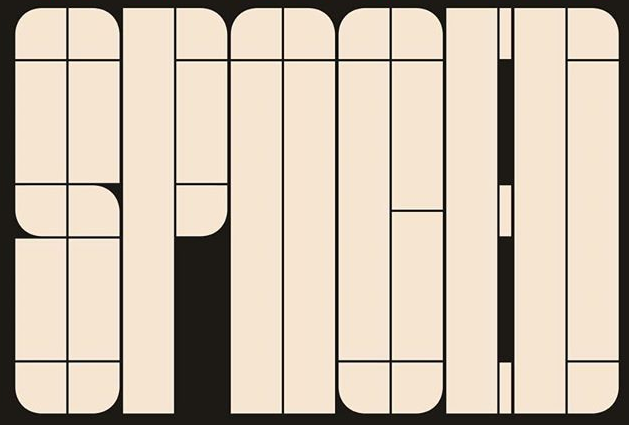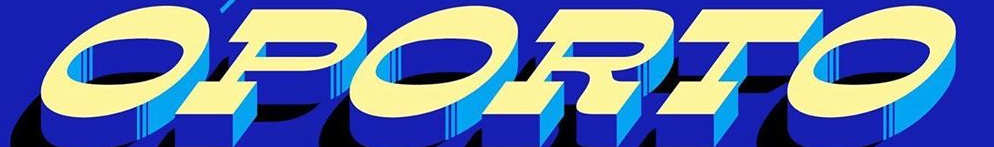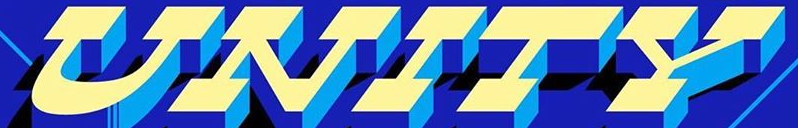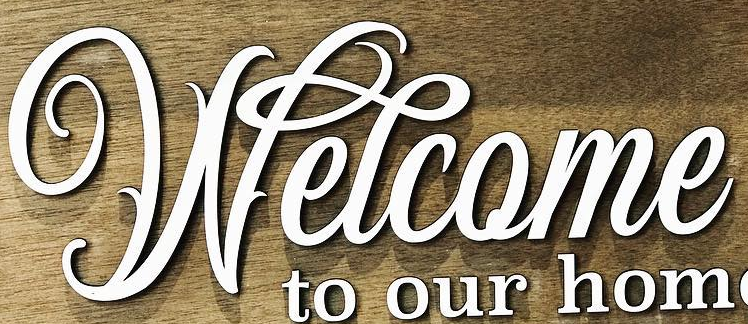What text is displayed in these images sequentially, separated by a semicolon? SPNOED; OPORTO; UNITY; Welcome 